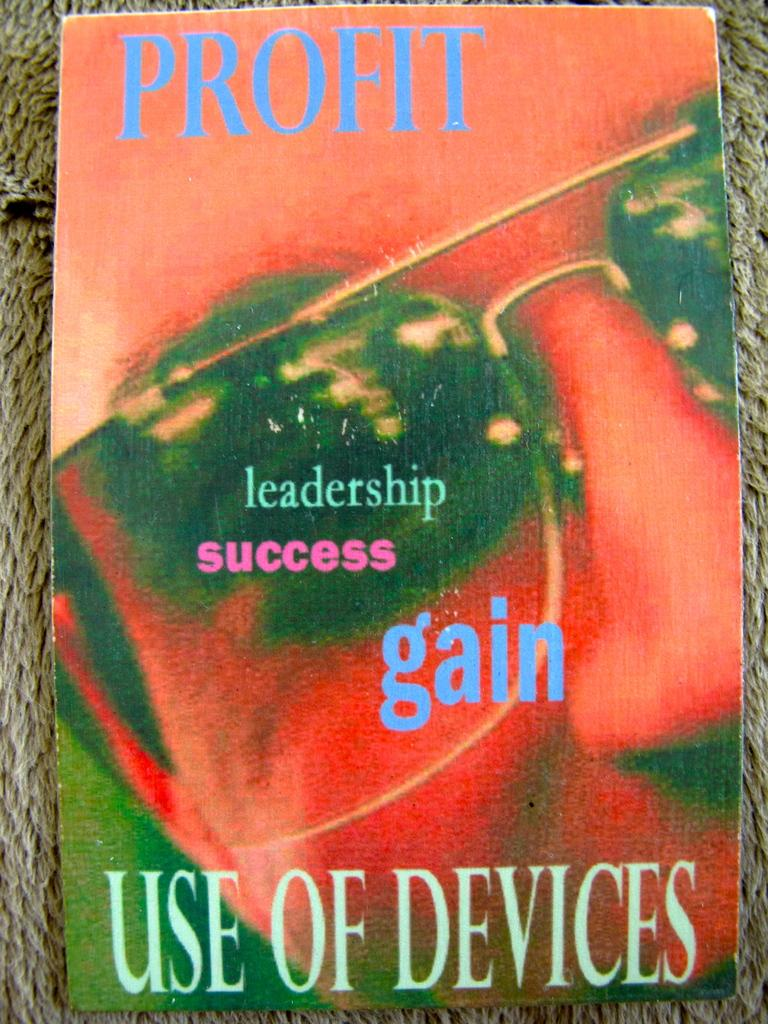<image>
Offer a succinct explanation of the picture presented. a book that says 'profit, use of devices' on it 